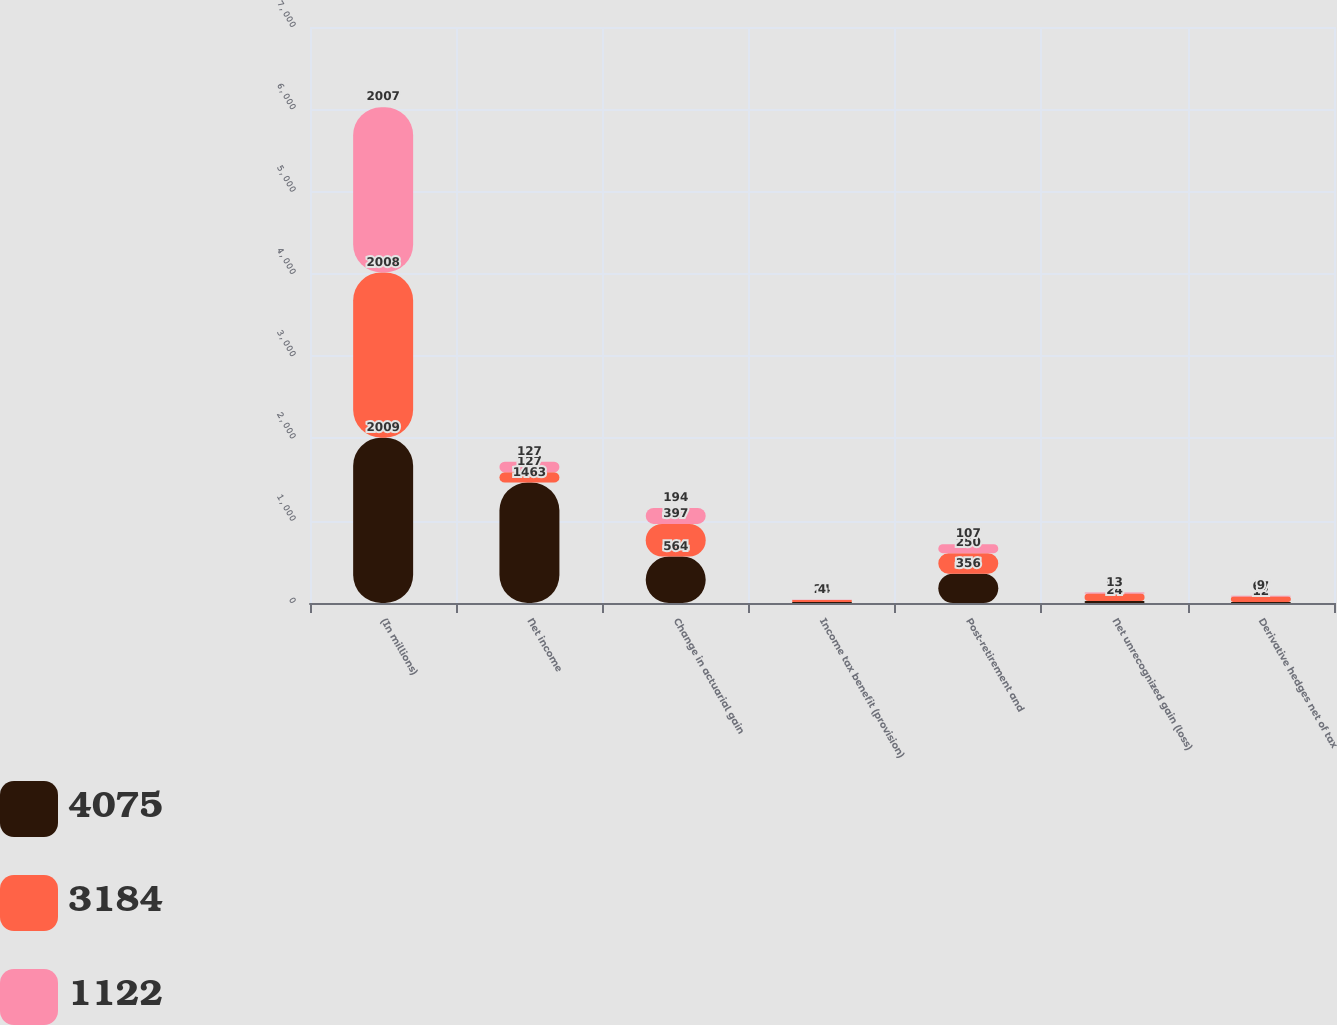Convert chart to OTSL. <chart><loc_0><loc_0><loc_500><loc_500><stacked_bar_chart><ecel><fcel>(In millions)<fcel>Net income<fcel>Change in actuarial gain<fcel>Income tax benefit (provision)<fcel>Post-retirement and<fcel>Net unrecognized gain (loss)<fcel>Derivative hedges net of tax<nl><fcel>4075<fcel>2009<fcel>1463<fcel>564<fcel>12<fcel>356<fcel>24<fcel>12<nl><fcel>3184<fcel>2008<fcel>127<fcel>397<fcel>24<fcel>250<fcel>91<fcel>67<nl><fcel>1122<fcel>2007<fcel>127<fcel>194<fcel>4<fcel>107<fcel>13<fcel>9<nl></chart> 